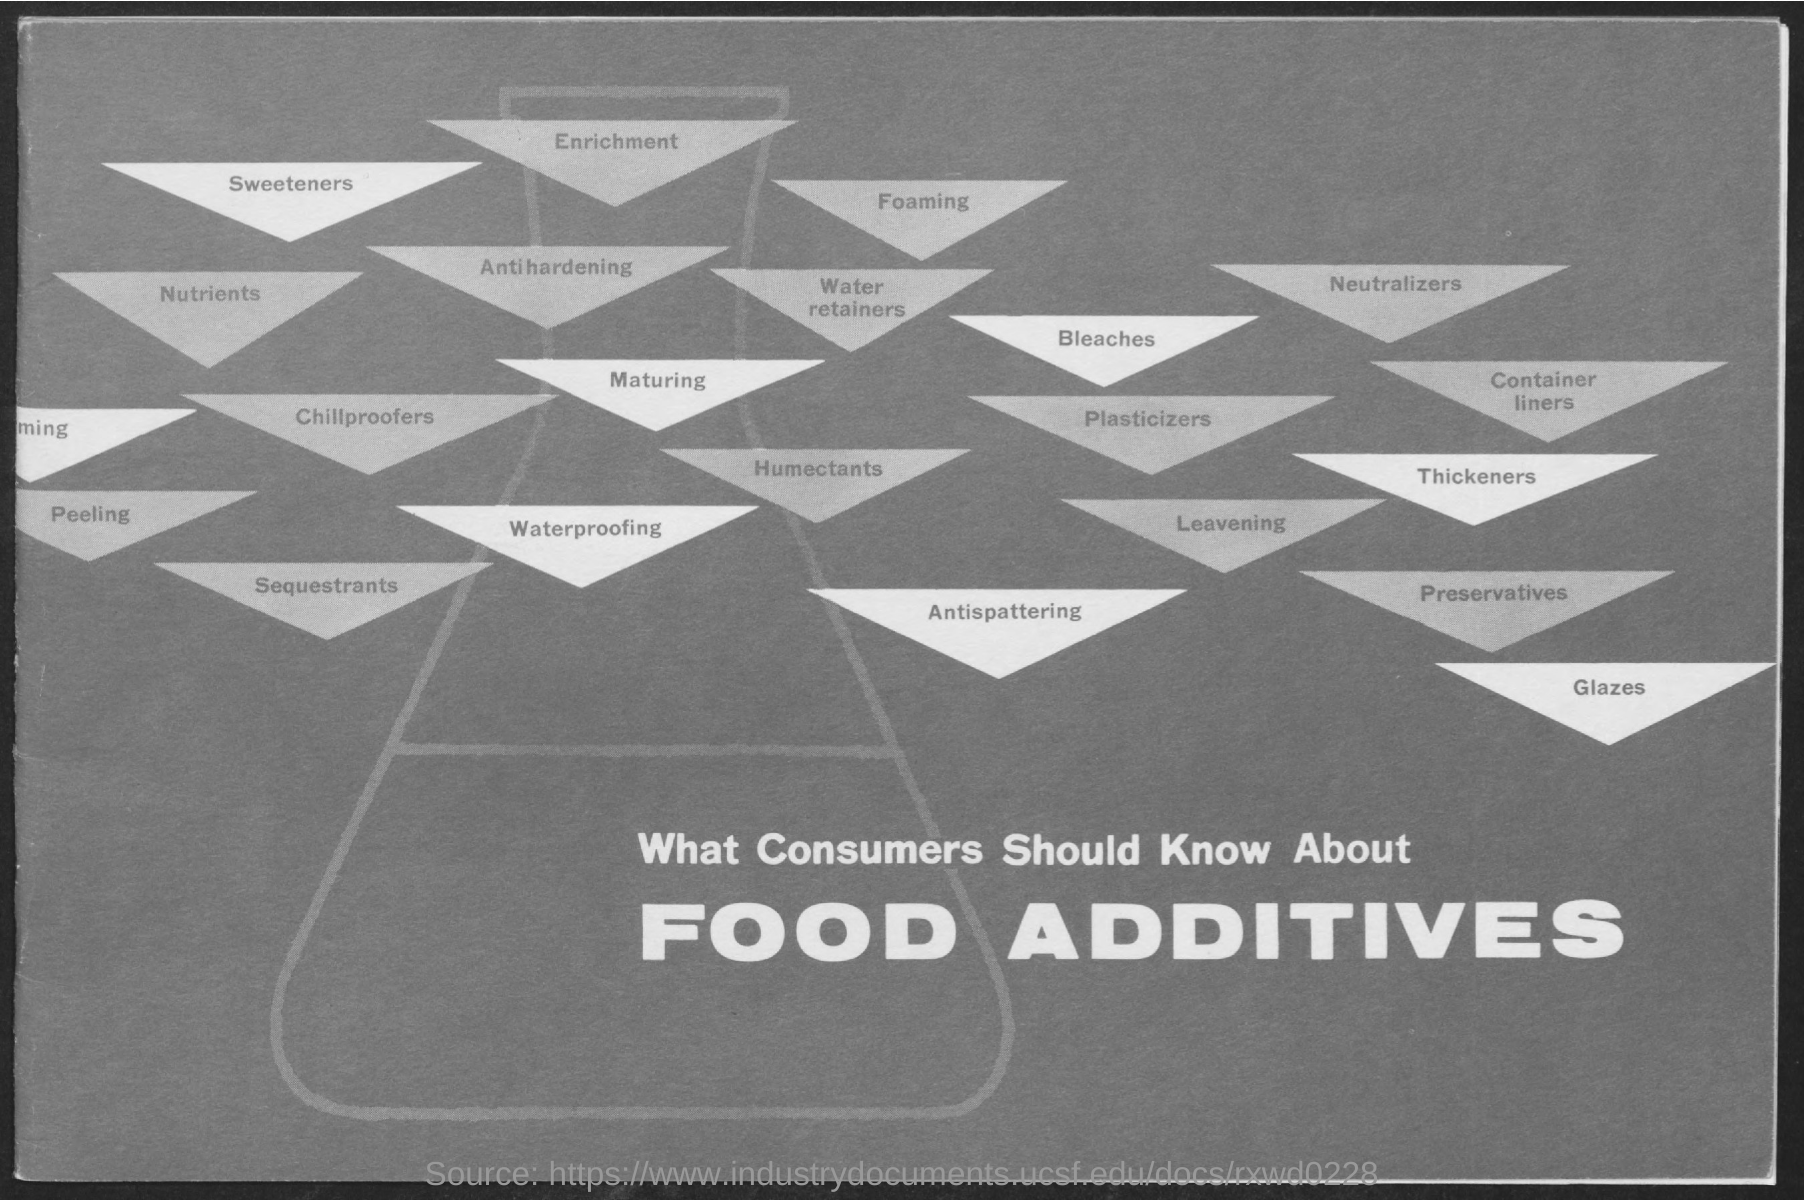What is the title?
Keep it short and to the point. Food Additives. 